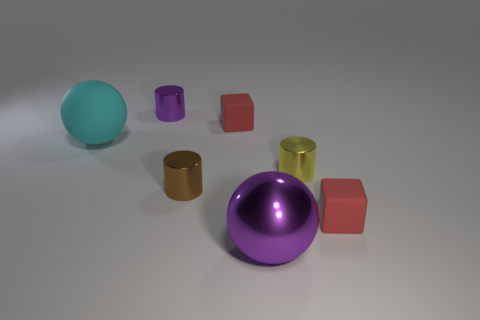Does the brown object to the right of the large rubber ball have the same shape as the tiny purple thing?
Your answer should be very brief. Yes. There is a small matte object in front of the brown object; what color is it?
Provide a short and direct response. Red. How many other objects are there of the same size as the rubber sphere?
Give a very brief answer. 1. Are there an equal number of small brown metallic objects that are on the left side of the brown shiny cylinder and red objects?
Offer a terse response. No. How many large purple objects have the same material as the purple ball?
Provide a succinct answer. 0. What is the color of the big ball that is made of the same material as the purple cylinder?
Your answer should be very brief. Purple. Is the shape of the brown thing the same as the tiny yellow thing?
Your answer should be very brief. Yes. Are there any tiny brown objects in front of the red rubber cube to the left of the tiny matte cube in front of the cyan matte sphere?
Your answer should be very brief. Yes. What number of metallic objects have the same color as the shiny ball?
Offer a terse response. 1. What is the shape of the brown metallic thing that is the same size as the purple cylinder?
Provide a short and direct response. Cylinder. 